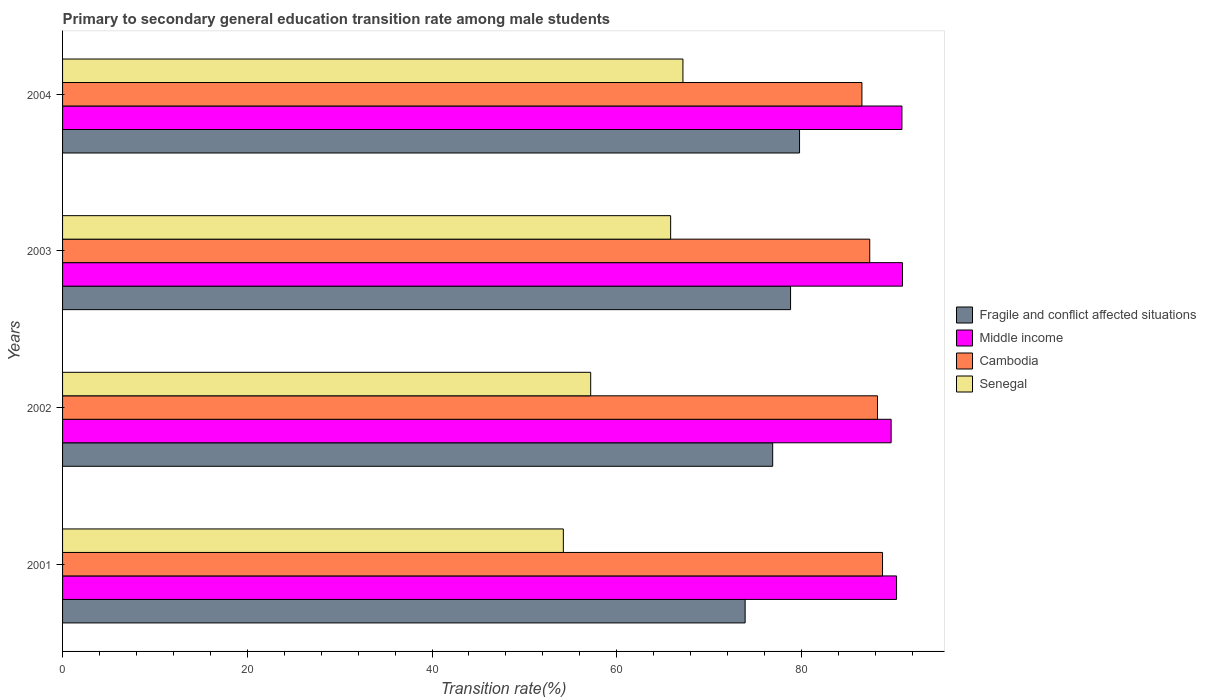How many groups of bars are there?
Keep it short and to the point. 4. Are the number of bars per tick equal to the number of legend labels?
Provide a short and direct response. Yes. In how many cases, is the number of bars for a given year not equal to the number of legend labels?
Offer a very short reply. 0. What is the transition rate in Fragile and conflict affected situations in 2002?
Your response must be concise. 76.88. Across all years, what is the maximum transition rate in Middle income?
Offer a very short reply. 90.94. Across all years, what is the minimum transition rate in Middle income?
Make the answer very short. 89.71. In which year was the transition rate in Middle income maximum?
Keep it short and to the point. 2003. In which year was the transition rate in Cambodia minimum?
Your answer should be compact. 2004. What is the total transition rate in Fragile and conflict affected situations in the graph?
Your answer should be very brief. 309.4. What is the difference between the transition rate in Fragile and conflict affected situations in 2002 and that in 2003?
Provide a succinct answer. -1.94. What is the difference between the transition rate in Senegal in 2001 and the transition rate in Middle income in 2003?
Your answer should be very brief. -36.72. What is the average transition rate in Middle income per year?
Your answer should be compact. 90.46. In the year 2003, what is the difference between the transition rate in Cambodia and transition rate in Fragile and conflict affected situations?
Make the answer very short. 8.57. What is the ratio of the transition rate in Middle income in 2001 to that in 2004?
Offer a very short reply. 0.99. Is the transition rate in Middle income in 2001 less than that in 2004?
Give a very brief answer. Yes. What is the difference between the highest and the second highest transition rate in Senegal?
Offer a very short reply. 1.33. What is the difference between the highest and the lowest transition rate in Senegal?
Offer a very short reply. 12.95. In how many years, is the transition rate in Fragile and conflict affected situations greater than the average transition rate in Fragile and conflict affected situations taken over all years?
Offer a terse response. 2. Is it the case that in every year, the sum of the transition rate in Fragile and conflict affected situations and transition rate in Middle income is greater than the sum of transition rate in Cambodia and transition rate in Senegal?
Offer a very short reply. Yes. What does the 4th bar from the top in 2003 represents?
Offer a very short reply. Fragile and conflict affected situations. What does the 4th bar from the bottom in 2003 represents?
Provide a succinct answer. Senegal. Is it the case that in every year, the sum of the transition rate in Fragile and conflict affected situations and transition rate in Cambodia is greater than the transition rate in Middle income?
Offer a very short reply. Yes. Are the values on the major ticks of X-axis written in scientific E-notation?
Offer a very short reply. No. Does the graph contain any zero values?
Your answer should be compact. No. Does the graph contain grids?
Make the answer very short. No. How many legend labels are there?
Provide a succinct answer. 4. What is the title of the graph?
Your answer should be compact. Primary to secondary general education transition rate among male students. Does "Albania" appear as one of the legend labels in the graph?
Ensure brevity in your answer.  No. What is the label or title of the X-axis?
Your answer should be compact. Transition rate(%). What is the label or title of the Y-axis?
Provide a succinct answer. Years. What is the Transition rate(%) of Fragile and conflict affected situations in 2001?
Offer a very short reply. 73.9. What is the Transition rate(%) in Middle income in 2001?
Ensure brevity in your answer.  90.3. What is the Transition rate(%) in Cambodia in 2001?
Offer a very short reply. 88.78. What is the Transition rate(%) of Senegal in 2001?
Keep it short and to the point. 54.22. What is the Transition rate(%) of Fragile and conflict affected situations in 2002?
Your response must be concise. 76.88. What is the Transition rate(%) of Middle income in 2002?
Ensure brevity in your answer.  89.71. What is the Transition rate(%) in Cambodia in 2002?
Your response must be concise. 88.23. What is the Transition rate(%) of Senegal in 2002?
Give a very brief answer. 57.18. What is the Transition rate(%) of Fragile and conflict affected situations in 2003?
Make the answer very short. 78.82. What is the Transition rate(%) of Middle income in 2003?
Give a very brief answer. 90.94. What is the Transition rate(%) in Cambodia in 2003?
Make the answer very short. 87.39. What is the Transition rate(%) of Senegal in 2003?
Offer a terse response. 65.84. What is the Transition rate(%) of Fragile and conflict affected situations in 2004?
Make the answer very short. 79.79. What is the Transition rate(%) of Middle income in 2004?
Keep it short and to the point. 90.88. What is the Transition rate(%) in Cambodia in 2004?
Keep it short and to the point. 86.54. What is the Transition rate(%) in Senegal in 2004?
Your response must be concise. 67.17. Across all years, what is the maximum Transition rate(%) of Fragile and conflict affected situations?
Give a very brief answer. 79.79. Across all years, what is the maximum Transition rate(%) in Middle income?
Your answer should be compact. 90.94. Across all years, what is the maximum Transition rate(%) in Cambodia?
Keep it short and to the point. 88.78. Across all years, what is the maximum Transition rate(%) in Senegal?
Make the answer very short. 67.17. Across all years, what is the minimum Transition rate(%) in Fragile and conflict affected situations?
Offer a terse response. 73.9. Across all years, what is the minimum Transition rate(%) of Middle income?
Offer a very short reply. 89.71. Across all years, what is the minimum Transition rate(%) of Cambodia?
Make the answer very short. 86.54. Across all years, what is the minimum Transition rate(%) of Senegal?
Your answer should be very brief. 54.22. What is the total Transition rate(%) in Fragile and conflict affected situations in the graph?
Offer a terse response. 309.4. What is the total Transition rate(%) in Middle income in the graph?
Keep it short and to the point. 361.82. What is the total Transition rate(%) of Cambodia in the graph?
Keep it short and to the point. 350.94. What is the total Transition rate(%) of Senegal in the graph?
Make the answer very short. 244.4. What is the difference between the Transition rate(%) in Fragile and conflict affected situations in 2001 and that in 2002?
Ensure brevity in your answer.  -2.98. What is the difference between the Transition rate(%) in Middle income in 2001 and that in 2002?
Provide a succinct answer. 0.59. What is the difference between the Transition rate(%) in Cambodia in 2001 and that in 2002?
Ensure brevity in your answer.  0.55. What is the difference between the Transition rate(%) of Senegal in 2001 and that in 2002?
Make the answer very short. -2.96. What is the difference between the Transition rate(%) of Fragile and conflict affected situations in 2001 and that in 2003?
Offer a very short reply. -4.92. What is the difference between the Transition rate(%) in Middle income in 2001 and that in 2003?
Ensure brevity in your answer.  -0.64. What is the difference between the Transition rate(%) of Cambodia in 2001 and that in 2003?
Offer a terse response. 1.38. What is the difference between the Transition rate(%) of Senegal in 2001 and that in 2003?
Ensure brevity in your answer.  -11.62. What is the difference between the Transition rate(%) of Fragile and conflict affected situations in 2001 and that in 2004?
Ensure brevity in your answer.  -5.89. What is the difference between the Transition rate(%) of Middle income in 2001 and that in 2004?
Make the answer very short. -0.58. What is the difference between the Transition rate(%) in Cambodia in 2001 and that in 2004?
Keep it short and to the point. 2.23. What is the difference between the Transition rate(%) of Senegal in 2001 and that in 2004?
Your answer should be very brief. -12.95. What is the difference between the Transition rate(%) of Fragile and conflict affected situations in 2002 and that in 2003?
Your answer should be very brief. -1.94. What is the difference between the Transition rate(%) in Middle income in 2002 and that in 2003?
Make the answer very short. -1.23. What is the difference between the Transition rate(%) in Cambodia in 2002 and that in 2003?
Your response must be concise. 0.84. What is the difference between the Transition rate(%) of Senegal in 2002 and that in 2003?
Give a very brief answer. -8.66. What is the difference between the Transition rate(%) in Fragile and conflict affected situations in 2002 and that in 2004?
Provide a short and direct response. -2.91. What is the difference between the Transition rate(%) in Middle income in 2002 and that in 2004?
Provide a succinct answer. -1.17. What is the difference between the Transition rate(%) of Cambodia in 2002 and that in 2004?
Your answer should be very brief. 1.68. What is the difference between the Transition rate(%) in Senegal in 2002 and that in 2004?
Provide a succinct answer. -9.99. What is the difference between the Transition rate(%) of Fragile and conflict affected situations in 2003 and that in 2004?
Your answer should be very brief. -0.97. What is the difference between the Transition rate(%) in Middle income in 2003 and that in 2004?
Ensure brevity in your answer.  0.06. What is the difference between the Transition rate(%) of Cambodia in 2003 and that in 2004?
Keep it short and to the point. 0.85. What is the difference between the Transition rate(%) of Senegal in 2003 and that in 2004?
Offer a very short reply. -1.33. What is the difference between the Transition rate(%) of Fragile and conflict affected situations in 2001 and the Transition rate(%) of Middle income in 2002?
Offer a very short reply. -15.81. What is the difference between the Transition rate(%) of Fragile and conflict affected situations in 2001 and the Transition rate(%) of Cambodia in 2002?
Provide a short and direct response. -14.33. What is the difference between the Transition rate(%) in Fragile and conflict affected situations in 2001 and the Transition rate(%) in Senegal in 2002?
Provide a succinct answer. 16.72. What is the difference between the Transition rate(%) in Middle income in 2001 and the Transition rate(%) in Cambodia in 2002?
Your response must be concise. 2.07. What is the difference between the Transition rate(%) in Middle income in 2001 and the Transition rate(%) in Senegal in 2002?
Your answer should be compact. 33.12. What is the difference between the Transition rate(%) of Cambodia in 2001 and the Transition rate(%) of Senegal in 2002?
Make the answer very short. 31.6. What is the difference between the Transition rate(%) of Fragile and conflict affected situations in 2001 and the Transition rate(%) of Middle income in 2003?
Provide a succinct answer. -17.04. What is the difference between the Transition rate(%) in Fragile and conflict affected situations in 2001 and the Transition rate(%) in Cambodia in 2003?
Offer a very short reply. -13.49. What is the difference between the Transition rate(%) in Fragile and conflict affected situations in 2001 and the Transition rate(%) in Senegal in 2003?
Provide a succinct answer. 8.07. What is the difference between the Transition rate(%) in Middle income in 2001 and the Transition rate(%) in Cambodia in 2003?
Keep it short and to the point. 2.9. What is the difference between the Transition rate(%) of Middle income in 2001 and the Transition rate(%) of Senegal in 2003?
Ensure brevity in your answer.  24.46. What is the difference between the Transition rate(%) of Cambodia in 2001 and the Transition rate(%) of Senegal in 2003?
Offer a terse response. 22.94. What is the difference between the Transition rate(%) in Fragile and conflict affected situations in 2001 and the Transition rate(%) in Middle income in 2004?
Provide a short and direct response. -16.98. What is the difference between the Transition rate(%) in Fragile and conflict affected situations in 2001 and the Transition rate(%) in Cambodia in 2004?
Your response must be concise. -12.64. What is the difference between the Transition rate(%) in Fragile and conflict affected situations in 2001 and the Transition rate(%) in Senegal in 2004?
Keep it short and to the point. 6.73. What is the difference between the Transition rate(%) in Middle income in 2001 and the Transition rate(%) in Cambodia in 2004?
Keep it short and to the point. 3.75. What is the difference between the Transition rate(%) in Middle income in 2001 and the Transition rate(%) in Senegal in 2004?
Keep it short and to the point. 23.13. What is the difference between the Transition rate(%) of Cambodia in 2001 and the Transition rate(%) of Senegal in 2004?
Offer a terse response. 21.61. What is the difference between the Transition rate(%) of Fragile and conflict affected situations in 2002 and the Transition rate(%) of Middle income in 2003?
Offer a very short reply. -14.06. What is the difference between the Transition rate(%) of Fragile and conflict affected situations in 2002 and the Transition rate(%) of Cambodia in 2003?
Ensure brevity in your answer.  -10.51. What is the difference between the Transition rate(%) of Fragile and conflict affected situations in 2002 and the Transition rate(%) of Senegal in 2003?
Offer a very short reply. 11.05. What is the difference between the Transition rate(%) in Middle income in 2002 and the Transition rate(%) in Cambodia in 2003?
Offer a very short reply. 2.32. What is the difference between the Transition rate(%) in Middle income in 2002 and the Transition rate(%) in Senegal in 2003?
Offer a very short reply. 23.87. What is the difference between the Transition rate(%) in Cambodia in 2002 and the Transition rate(%) in Senegal in 2003?
Keep it short and to the point. 22.39. What is the difference between the Transition rate(%) of Fragile and conflict affected situations in 2002 and the Transition rate(%) of Middle income in 2004?
Your answer should be very brief. -13.99. What is the difference between the Transition rate(%) in Fragile and conflict affected situations in 2002 and the Transition rate(%) in Cambodia in 2004?
Provide a succinct answer. -9.66. What is the difference between the Transition rate(%) of Fragile and conflict affected situations in 2002 and the Transition rate(%) of Senegal in 2004?
Offer a terse response. 9.72. What is the difference between the Transition rate(%) in Middle income in 2002 and the Transition rate(%) in Cambodia in 2004?
Ensure brevity in your answer.  3.16. What is the difference between the Transition rate(%) in Middle income in 2002 and the Transition rate(%) in Senegal in 2004?
Ensure brevity in your answer.  22.54. What is the difference between the Transition rate(%) of Cambodia in 2002 and the Transition rate(%) of Senegal in 2004?
Your response must be concise. 21.06. What is the difference between the Transition rate(%) in Fragile and conflict affected situations in 2003 and the Transition rate(%) in Middle income in 2004?
Offer a very short reply. -12.06. What is the difference between the Transition rate(%) of Fragile and conflict affected situations in 2003 and the Transition rate(%) of Cambodia in 2004?
Offer a very short reply. -7.72. What is the difference between the Transition rate(%) of Fragile and conflict affected situations in 2003 and the Transition rate(%) of Senegal in 2004?
Your answer should be compact. 11.65. What is the difference between the Transition rate(%) in Middle income in 2003 and the Transition rate(%) in Cambodia in 2004?
Give a very brief answer. 4.4. What is the difference between the Transition rate(%) of Middle income in 2003 and the Transition rate(%) of Senegal in 2004?
Give a very brief answer. 23.77. What is the difference between the Transition rate(%) in Cambodia in 2003 and the Transition rate(%) in Senegal in 2004?
Your answer should be compact. 20.23. What is the average Transition rate(%) of Fragile and conflict affected situations per year?
Offer a very short reply. 77.35. What is the average Transition rate(%) in Middle income per year?
Your answer should be compact. 90.46. What is the average Transition rate(%) in Cambodia per year?
Your answer should be very brief. 87.74. What is the average Transition rate(%) of Senegal per year?
Your answer should be very brief. 61.1. In the year 2001, what is the difference between the Transition rate(%) of Fragile and conflict affected situations and Transition rate(%) of Middle income?
Ensure brevity in your answer.  -16.39. In the year 2001, what is the difference between the Transition rate(%) in Fragile and conflict affected situations and Transition rate(%) in Cambodia?
Your answer should be compact. -14.88. In the year 2001, what is the difference between the Transition rate(%) of Fragile and conflict affected situations and Transition rate(%) of Senegal?
Your response must be concise. 19.68. In the year 2001, what is the difference between the Transition rate(%) of Middle income and Transition rate(%) of Cambodia?
Make the answer very short. 1.52. In the year 2001, what is the difference between the Transition rate(%) in Middle income and Transition rate(%) in Senegal?
Offer a terse response. 36.08. In the year 2001, what is the difference between the Transition rate(%) of Cambodia and Transition rate(%) of Senegal?
Ensure brevity in your answer.  34.56. In the year 2002, what is the difference between the Transition rate(%) of Fragile and conflict affected situations and Transition rate(%) of Middle income?
Provide a succinct answer. -12.82. In the year 2002, what is the difference between the Transition rate(%) in Fragile and conflict affected situations and Transition rate(%) in Cambodia?
Your response must be concise. -11.34. In the year 2002, what is the difference between the Transition rate(%) of Fragile and conflict affected situations and Transition rate(%) of Senegal?
Make the answer very short. 19.7. In the year 2002, what is the difference between the Transition rate(%) of Middle income and Transition rate(%) of Cambodia?
Your answer should be very brief. 1.48. In the year 2002, what is the difference between the Transition rate(%) in Middle income and Transition rate(%) in Senegal?
Provide a succinct answer. 32.53. In the year 2002, what is the difference between the Transition rate(%) in Cambodia and Transition rate(%) in Senegal?
Provide a succinct answer. 31.05. In the year 2003, what is the difference between the Transition rate(%) in Fragile and conflict affected situations and Transition rate(%) in Middle income?
Provide a short and direct response. -12.12. In the year 2003, what is the difference between the Transition rate(%) of Fragile and conflict affected situations and Transition rate(%) of Cambodia?
Ensure brevity in your answer.  -8.57. In the year 2003, what is the difference between the Transition rate(%) of Fragile and conflict affected situations and Transition rate(%) of Senegal?
Give a very brief answer. 12.98. In the year 2003, what is the difference between the Transition rate(%) of Middle income and Transition rate(%) of Cambodia?
Keep it short and to the point. 3.55. In the year 2003, what is the difference between the Transition rate(%) in Middle income and Transition rate(%) in Senegal?
Your answer should be very brief. 25.1. In the year 2003, what is the difference between the Transition rate(%) of Cambodia and Transition rate(%) of Senegal?
Your answer should be very brief. 21.56. In the year 2004, what is the difference between the Transition rate(%) in Fragile and conflict affected situations and Transition rate(%) in Middle income?
Provide a short and direct response. -11.09. In the year 2004, what is the difference between the Transition rate(%) in Fragile and conflict affected situations and Transition rate(%) in Cambodia?
Your response must be concise. -6.75. In the year 2004, what is the difference between the Transition rate(%) in Fragile and conflict affected situations and Transition rate(%) in Senegal?
Ensure brevity in your answer.  12.63. In the year 2004, what is the difference between the Transition rate(%) of Middle income and Transition rate(%) of Cambodia?
Give a very brief answer. 4.33. In the year 2004, what is the difference between the Transition rate(%) in Middle income and Transition rate(%) in Senegal?
Give a very brief answer. 23.71. In the year 2004, what is the difference between the Transition rate(%) in Cambodia and Transition rate(%) in Senegal?
Ensure brevity in your answer.  19.38. What is the ratio of the Transition rate(%) of Fragile and conflict affected situations in 2001 to that in 2002?
Offer a terse response. 0.96. What is the ratio of the Transition rate(%) in Middle income in 2001 to that in 2002?
Your answer should be very brief. 1.01. What is the ratio of the Transition rate(%) in Senegal in 2001 to that in 2002?
Make the answer very short. 0.95. What is the ratio of the Transition rate(%) in Fragile and conflict affected situations in 2001 to that in 2003?
Your response must be concise. 0.94. What is the ratio of the Transition rate(%) in Middle income in 2001 to that in 2003?
Offer a very short reply. 0.99. What is the ratio of the Transition rate(%) in Cambodia in 2001 to that in 2003?
Give a very brief answer. 1.02. What is the ratio of the Transition rate(%) of Senegal in 2001 to that in 2003?
Offer a terse response. 0.82. What is the ratio of the Transition rate(%) of Fragile and conflict affected situations in 2001 to that in 2004?
Make the answer very short. 0.93. What is the ratio of the Transition rate(%) in Cambodia in 2001 to that in 2004?
Make the answer very short. 1.03. What is the ratio of the Transition rate(%) of Senegal in 2001 to that in 2004?
Keep it short and to the point. 0.81. What is the ratio of the Transition rate(%) in Fragile and conflict affected situations in 2002 to that in 2003?
Your response must be concise. 0.98. What is the ratio of the Transition rate(%) in Middle income in 2002 to that in 2003?
Give a very brief answer. 0.99. What is the ratio of the Transition rate(%) of Cambodia in 2002 to that in 2003?
Your response must be concise. 1.01. What is the ratio of the Transition rate(%) in Senegal in 2002 to that in 2003?
Your response must be concise. 0.87. What is the ratio of the Transition rate(%) in Fragile and conflict affected situations in 2002 to that in 2004?
Give a very brief answer. 0.96. What is the ratio of the Transition rate(%) of Middle income in 2002 to that in 2004?
Keep it short and to the point. 0.99. What is the ratio of the Transition rate(%) in Cambodia in 2002 to that in 2004?
Keep it short and to the point. 1.02. What is the ratio of the Transition rate(%) in Senegal in 2002 to that in 2004?
Your response must be concise. 0.85. What is the ratio of the Transition rate(%) of Cambodia in 2003 to that in 2004?
Make the answer very short. 1.01. What is the ratio of the Transition rate(%) in Senegal in 2003 to that in 2004?
Your answer should be compact. 0.98. What is the difference between the highest and the second highest Transition rate(%) of Middle income?
Your answer should be very brief. 0.06. What is the difference between the highest and the second highest Transition rate(%) of Cambodia?
Provide a succinct answer. 0.55. What is the difference between the highest and the second highest Transition rate(%) of Senegal?
Your response must be concise. 1.33. What is the difference between the highest and the lowest Transition rate(%) in Fragile and conflict affected situations?
Provide a short and direct response. 5.89. What is the difference between the highest and the lowest Transition rate(%) of Middle income?
Offer a very short reply. 1.23. What is the difference between the highest and the lowest Transition rate(%) of Cambodia?
Your answer should be very brief. 2.23. What is the difference between the highest and the lowest Transition rate(%) of Senegal?
Ensure brevity in your answer.  12.95. 